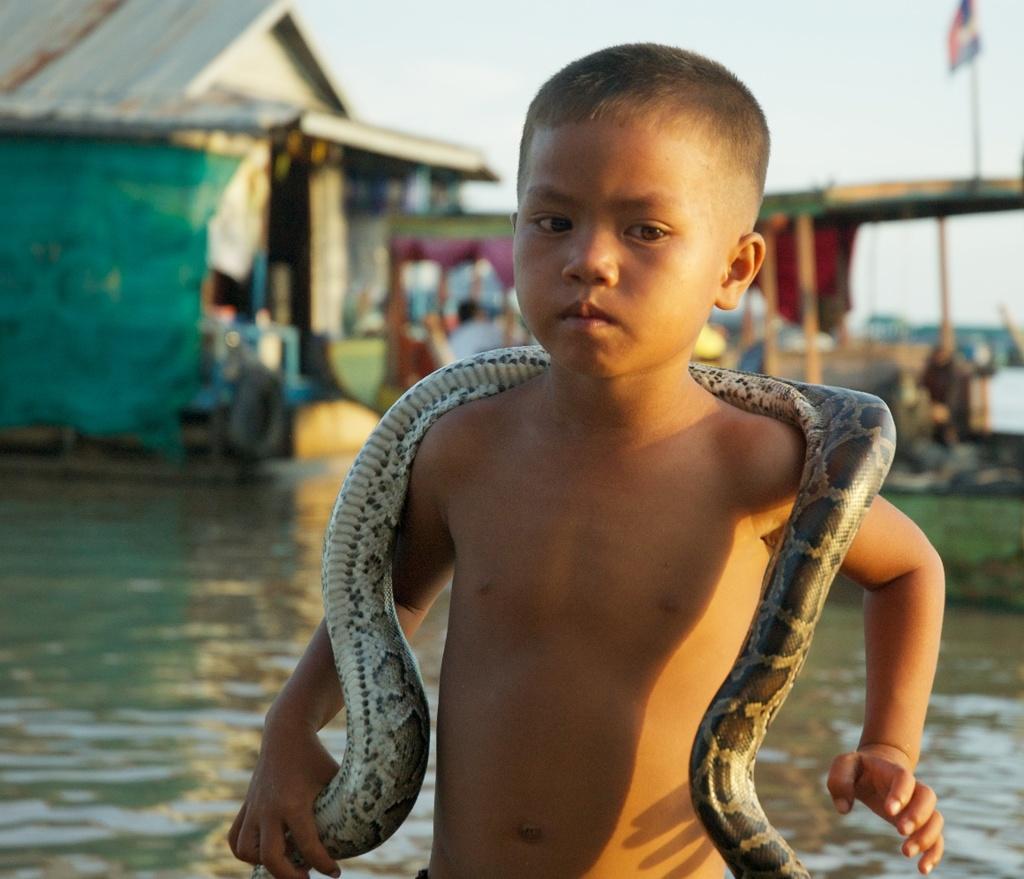Could you give a brief overview of what you see in this image? In this image I can see the child holding a snake. In the background there is a hut,sky,flag and I can see a river under the hut. 